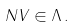<formula> <loc_0><loc_0><loc_500><loc_500>N V \in \Lambda \, .</formula> 